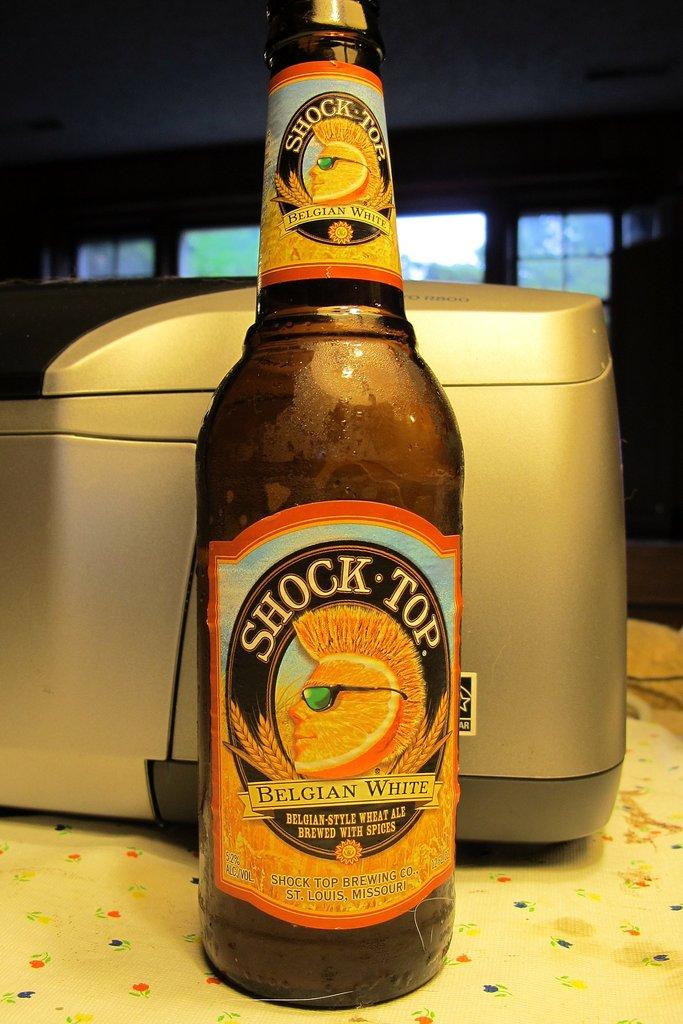What brand beer is in the bottle?
Offer a terse response. Shock top. What is the beer's flavor?
Offer a very short reply. Belgian white. 